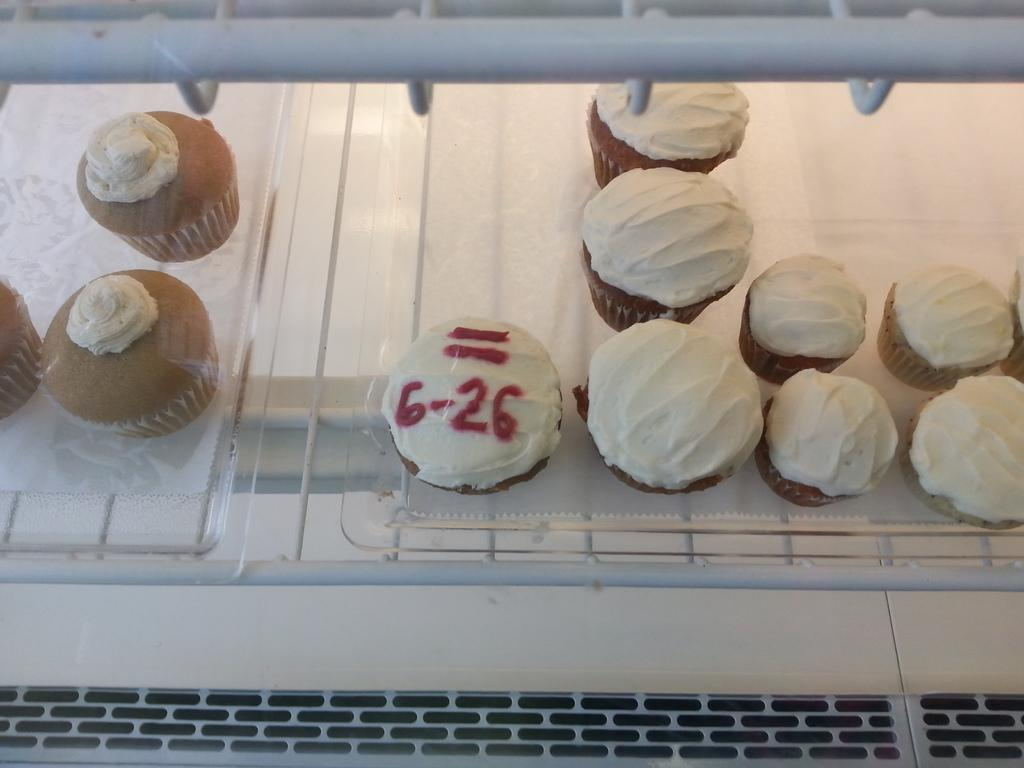What type of dessert can be seen in the image? There are cupcakes with cream in the image. Where are the cupcakes located? The cupcakes are placed in a refrigerator grill. How many eyes can be seen on the cupcakes in the image? There are no eyes visible on the cupcakes in the image. What type of fruit is being served at the event in the image? There is no event or fruit present in the image; it only features cupcakes with cream in a refrigerator grill. 